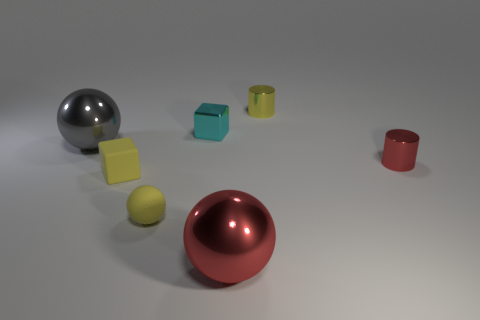There is another large object that is the same shape as the gray shiny object; what is it made of?
Offer a very short reply. Metal. How many things are small yellow objects behind the cyan metallic cube or large balls?
Make the answer very short. 3. The gray object that is made of the same material as the cyan object is what shape?
Provide a short and direct response. Sphere. What number of cyan shiny things have the same shape as the small red metal thing?
Keep it short and to the point. 0. What is the material of the big gray thing?
Provide a succinct answer. Metal. Does the tiny matte ball have the same color as the small shiny thing in front of the big gray ball?
Your answer should be very brief. No. How many cubes are big shiny objects or tiny matte things?
Offer a very short reply. 1. There is a small cylinder that is behind the gray sphere; what color is it?
Provide a short and direct response. Yellow. There is a matte thing that is the same color as the small rubber cube; what is its shape?
Offer a terse response. Sphere. How many cyan things have the same size as the yellow matte block?
Make the answer very short. 1. 